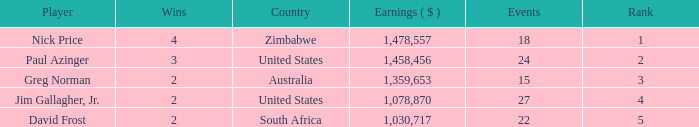How many events are in South Africa? 22.0. 